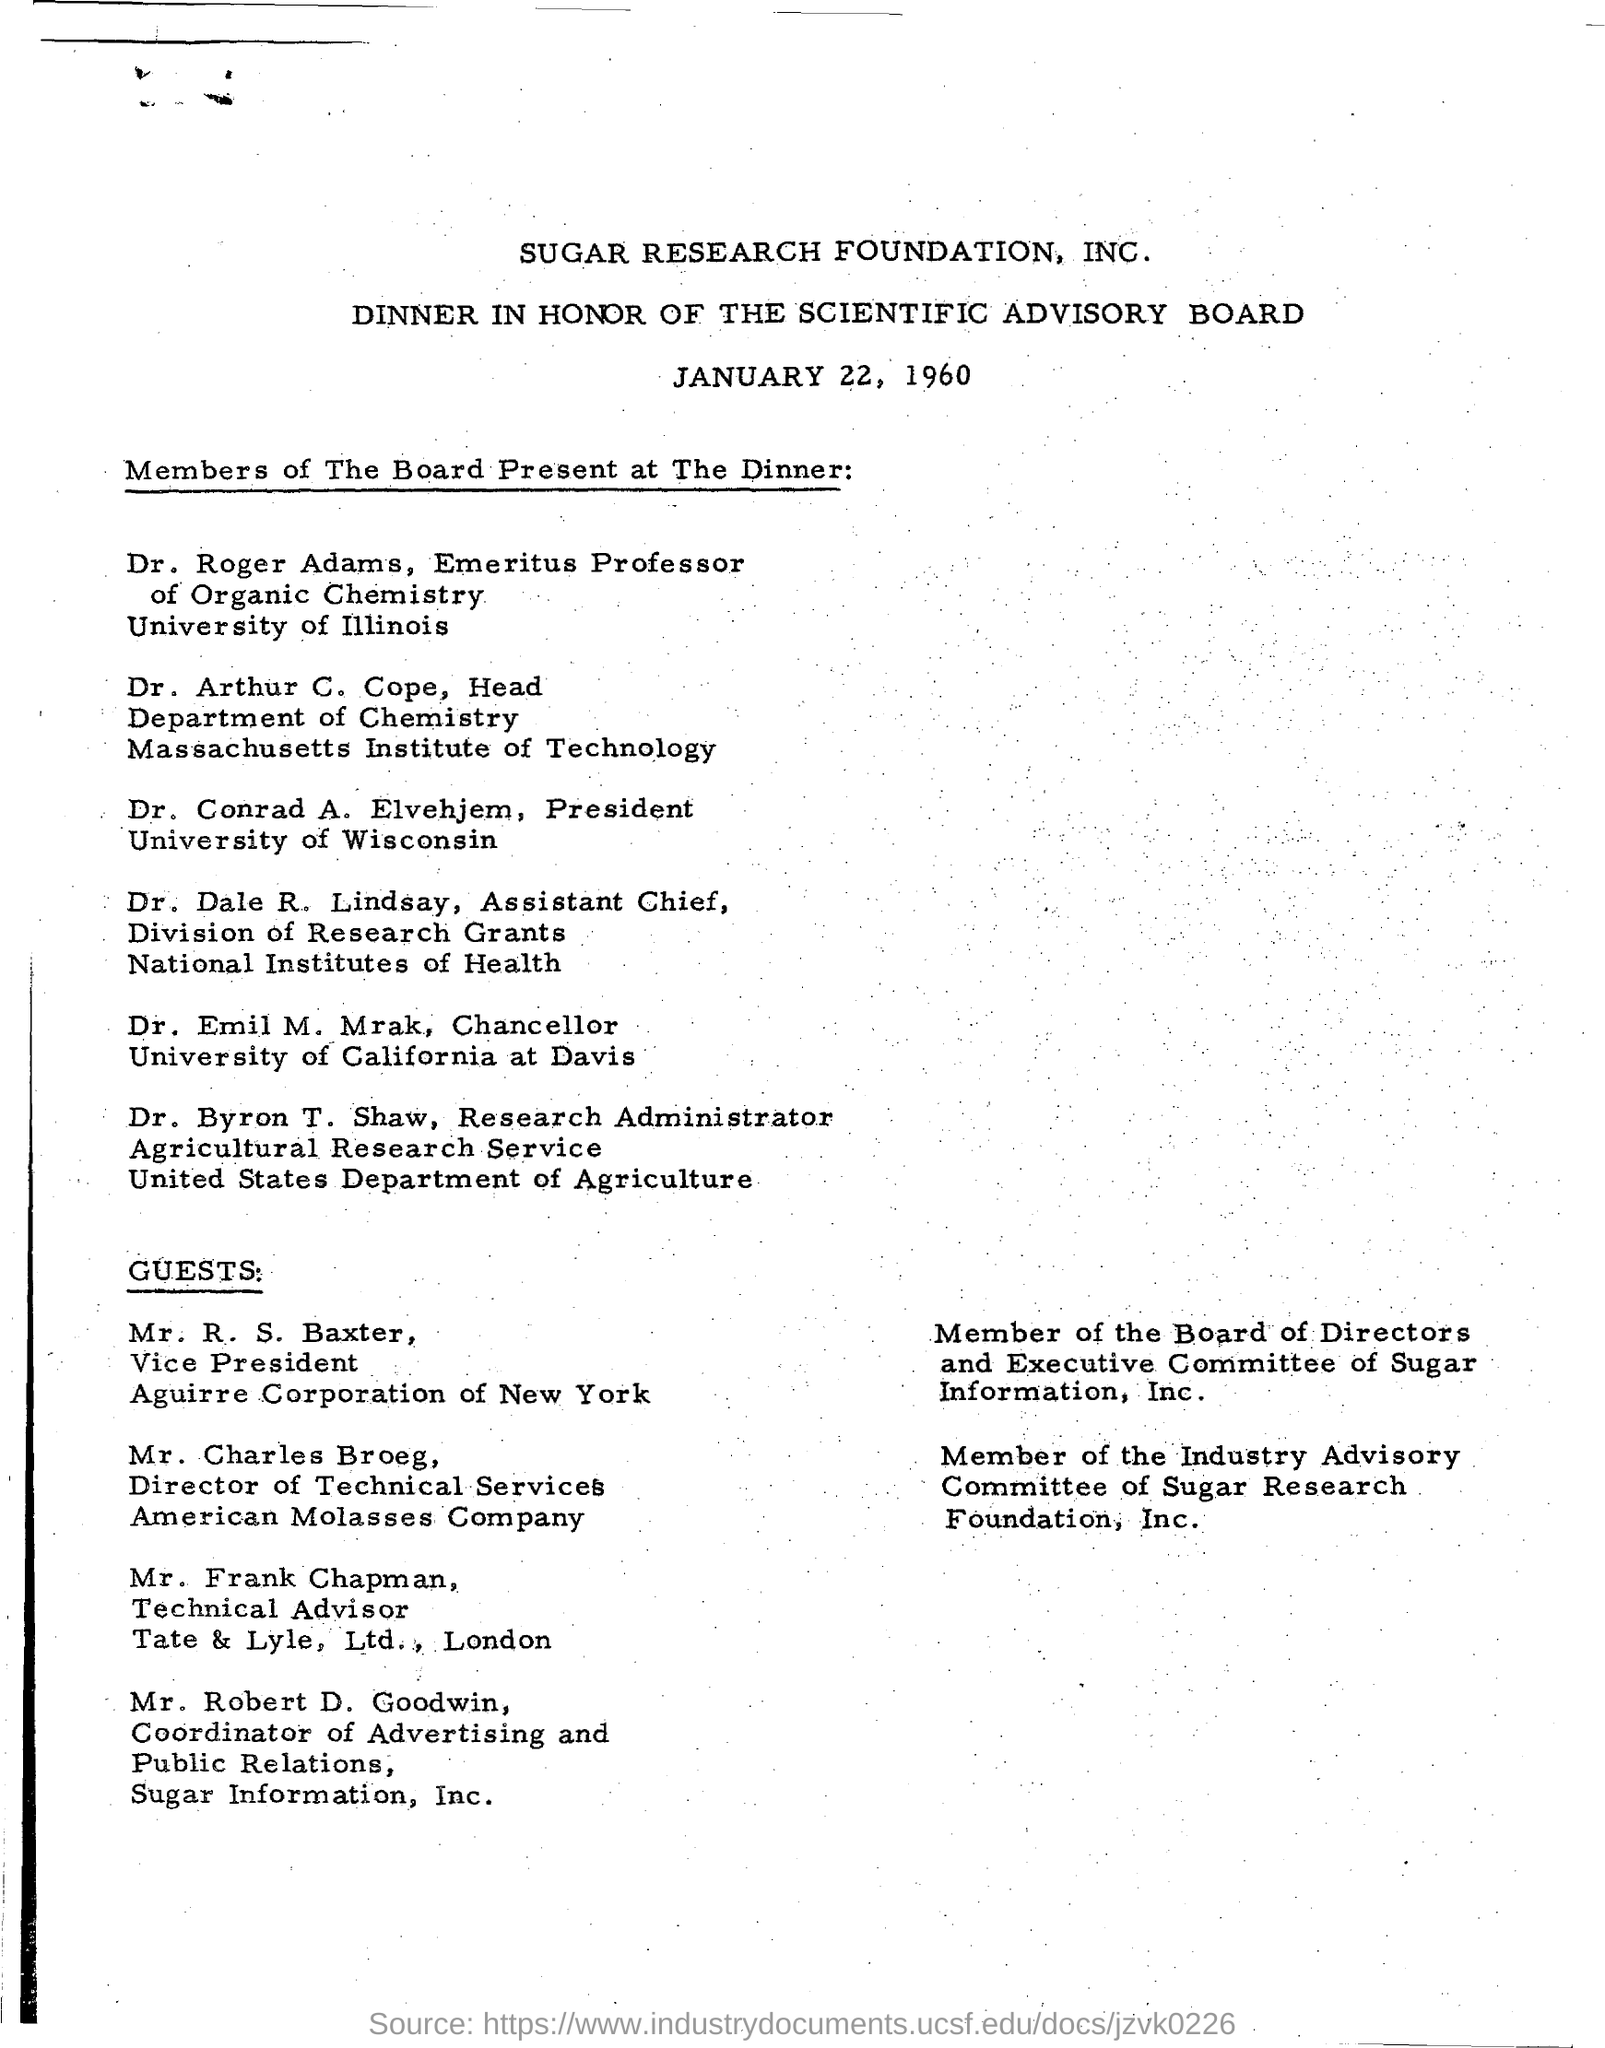On which date the dinner is scheduled ?
Provide a short and direct response. January 22, 1960. What is the designation of dr. emil m. mrak ?
Offer a very short reply. CHANCELLOR. What is the designation of dr. byron t. shaw ?
Give a very brief answer. Research administrator. 